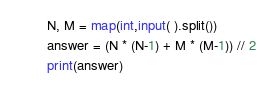<code> <loc_0><loc_0><loc_500><loc_500><_Python_>N, M = map(int,input( ).split())
answer = (N * (N-1) + M * (M-1)) // 2
print(answer)</code> 